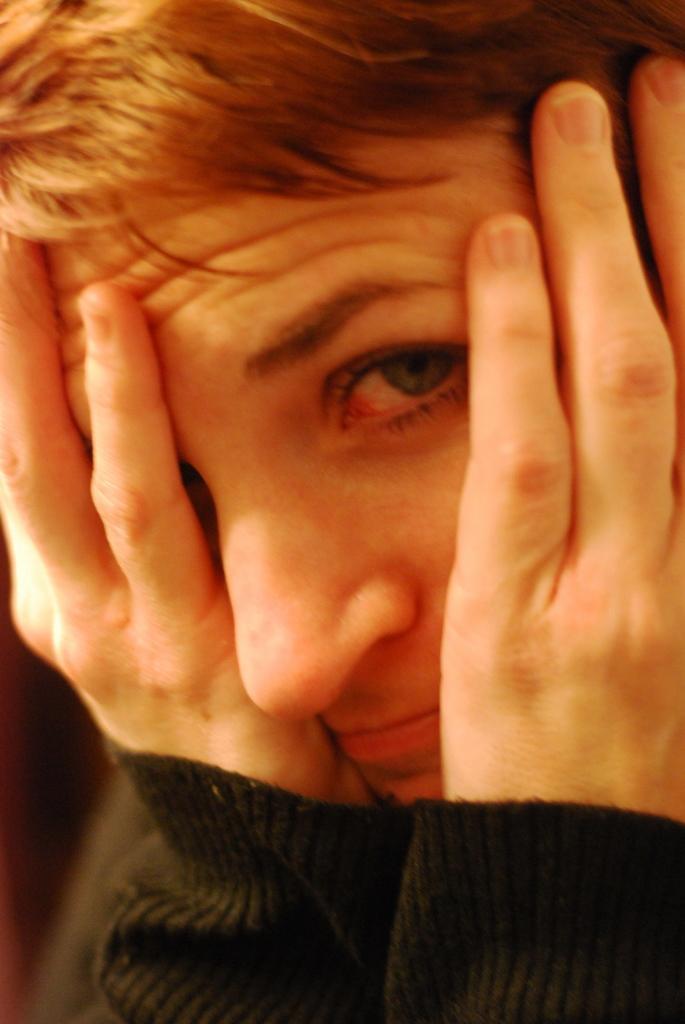How would you summarize this image in a sentence or two? In this image I can see a person wearing black t shirt and covering his face with his hands. 